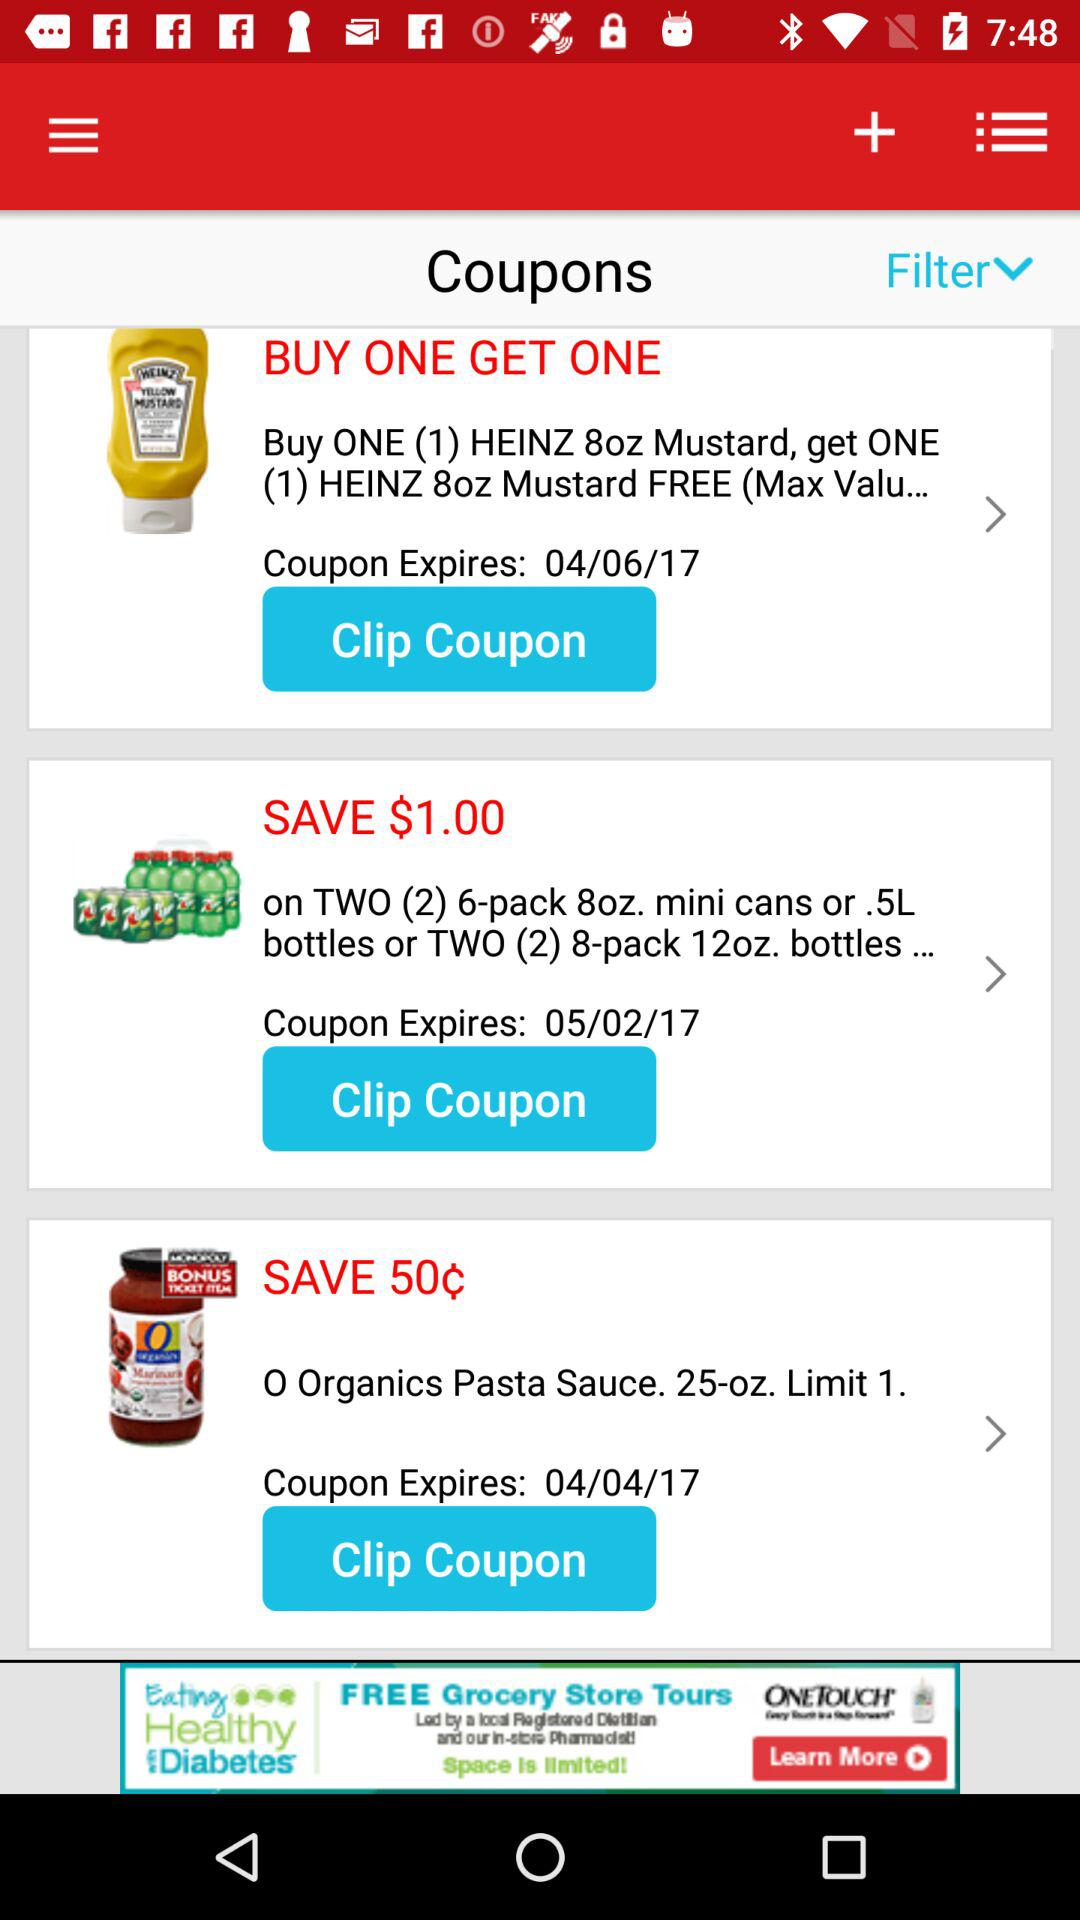How much money do I save on "TWO (2) 6-pack 8oz. mini cans"? You save $1 on "TWO (2) 6-pack 8oz. mini cans". 